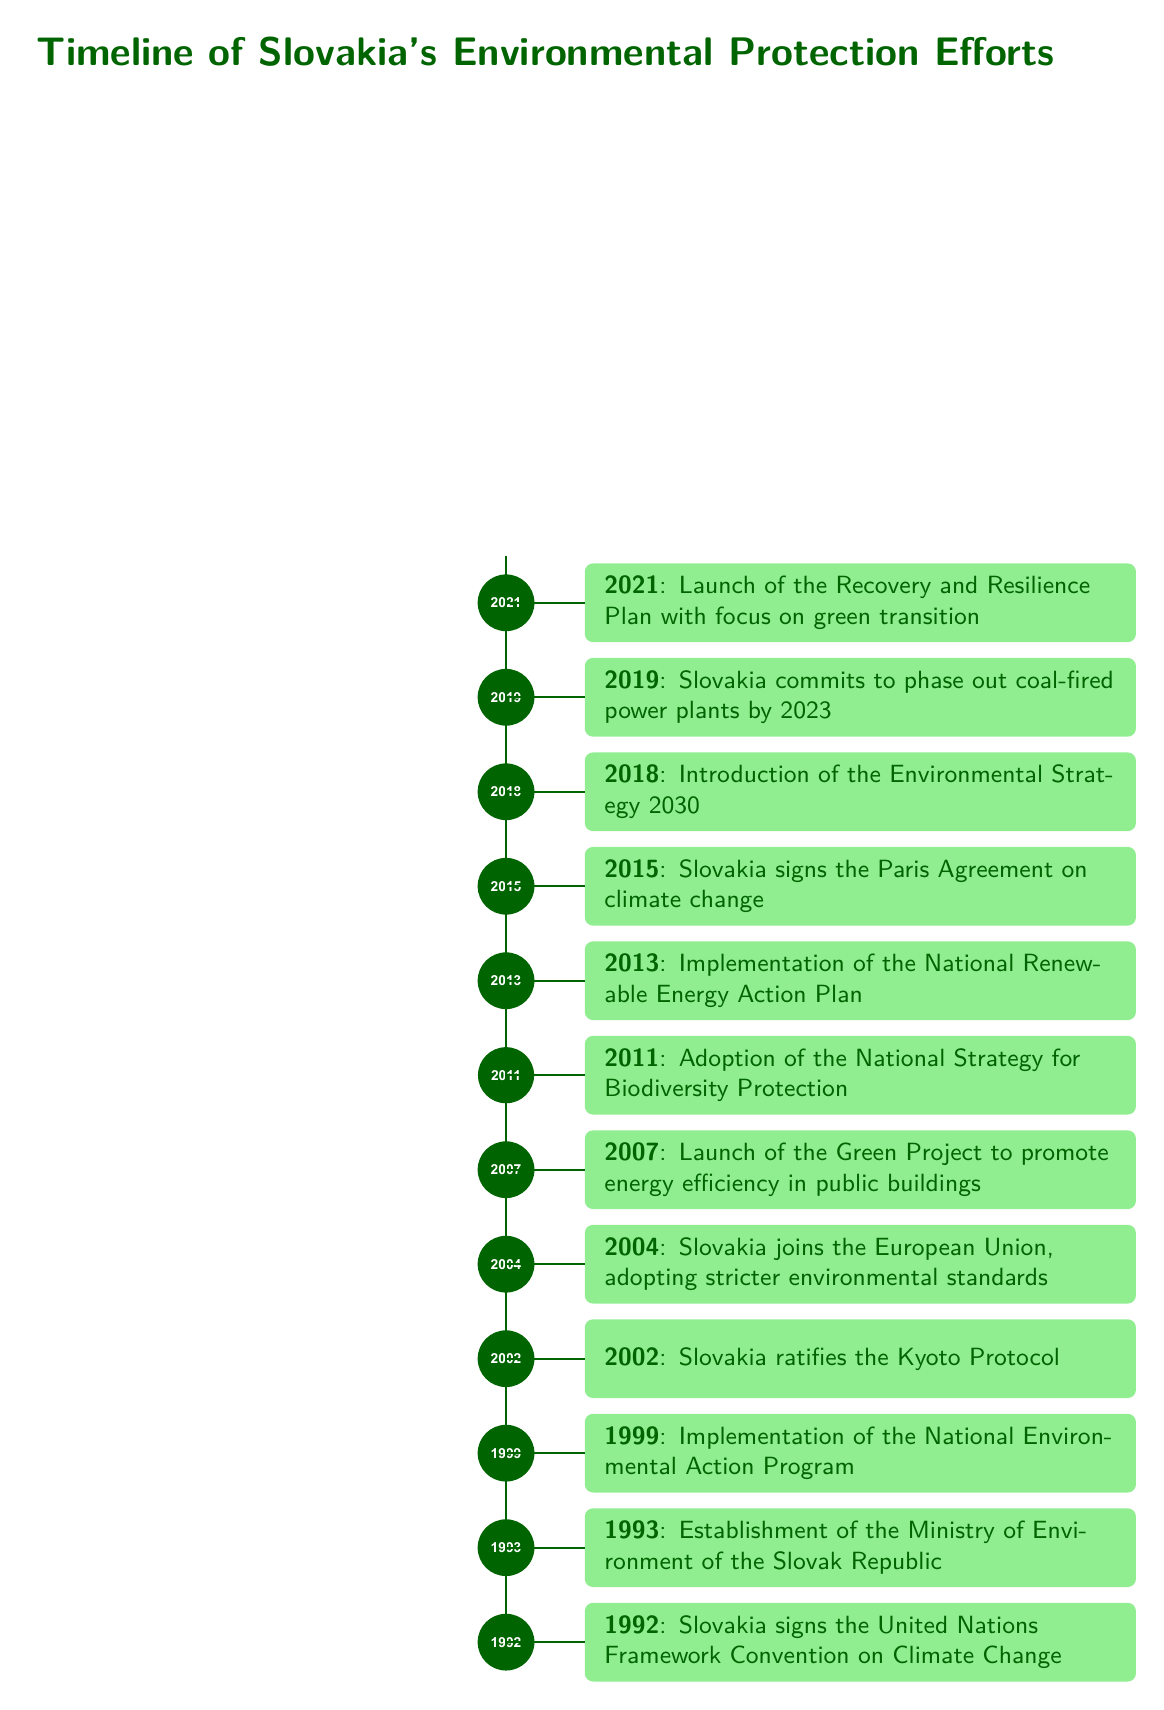How many years were there between the signing of the United Nations Framework Convention on Climate Change and the adoption of the National Strategy for Biodiversity Protection? The United Nations Framework Convention was signed in 1992 and the National Strategy for Biodiversity Protection was adopted in 2011. The difference is 2011 - 1992 = 19 years.
Answer: 19 years What was the trend of Slovakia's environmental initiatives from 1992 to 2021 in terms of annual occurrences? Reviewing the timeline, one can see there is an increasing trend; the events became more frequent towards the later years, particularly with the focus on green transition seen in the 2021 initiative, indicating a growing emphasis on environmental issues over time.
Answer: Increasing trend How does the introduction of the Environmental Strategy 2030 in 2018 relate to earlier initiatives? The Environmental Strategy 2030 introduced in 2018 builds on earlier initiatives like the National Renewable Energy Action Plan in 2013 and reflects a long-term commitment to environmental protection, aiming for systematic improvements and alignment with EU standards established in 2004.
Answer: Builds on earlier initiatives What significant environmental change occurred in Slovakia in 2011? The significant environmental change in 2011 was the adoption of the National Strategy for Biodiversity Protection, a key step towards conserving biodiversity in Slovakia.
Answer: Adoption of the National Strategy for Biodiversity Protection What specific goal was established in 2007 regarding public buildings? In 2007, Slovakia launched the Green Project, which aimed to promote energy efficiency in public buildings, reflecting a dedication to improving energy use in governmental structures.
Answer: Promote energy efficiency in public buildings 